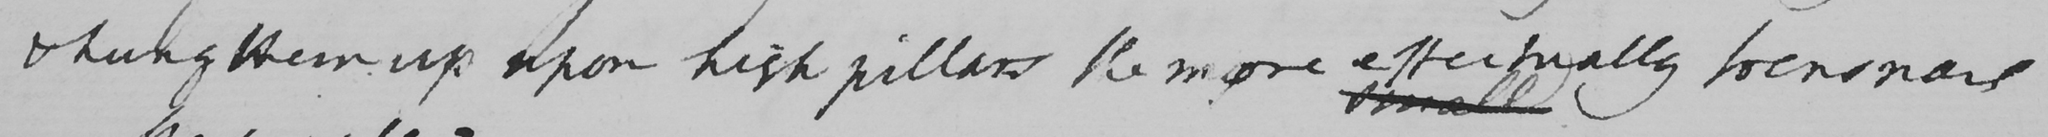Transcribe the text shown in this historical manuscript line. & hung them up upon high pillars the more effectually to ensnare 